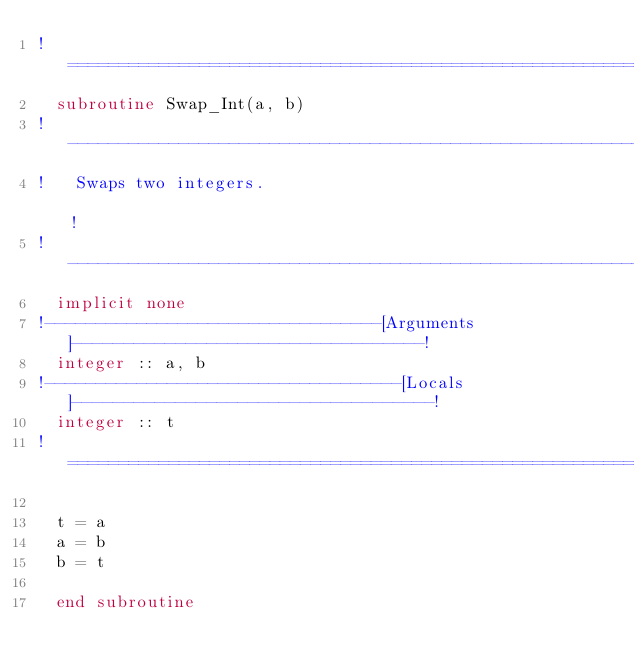<code> <loc_0><loc_0><loc_500><loc_500><_FORTRAN_>!==============================================================================!
  subroutine Swap_Int(a, b)
!------------------------------------------------------------------------------!
!   Swaps two integers.                                                        !
!------------------------------------------------------------------------------!
  implicit none
!---------------------------------[Arguments]----------------------------------!
  integer :: a, b
!-----------------------------------[Locals]-----------------------------------!
  integer :: t
!==============================================================================!

  t = a
  a = b
  b = t

  end subroutine
</code> 